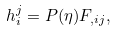Convert formula to latex. <formula><loc_0><loc_0><loc_500><loc_500>h ^ { j } _ { i } = P ( \eta ) F _ { , i j } ,</formula> 